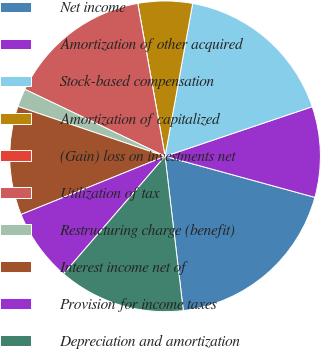Convert chart. <chart><loc_0><loc_0><loc_500><loc_500><pie_chart><fcel>Net income<fcel>Amortization of other acquired<fcel>Stock-based compensation<fcel>Amortization of capitalized<fcel>(Gain) loss on investments net<fcel>Utilization of tax<fcel>Restructuring charge (benefit)<fcel>Interest income net of<fcel>Provision for income taxes<fcel>Depreciation and amortization<nl><fcel>18.87%<fcel>9.43%<fcel>16.98%<fcel>5.66%<fcel>0.0%<fcel>15.09%<fcel>1.89%<fcel>11.32%<fcel>7.55%<fcel>13.21%<nl></chart> 